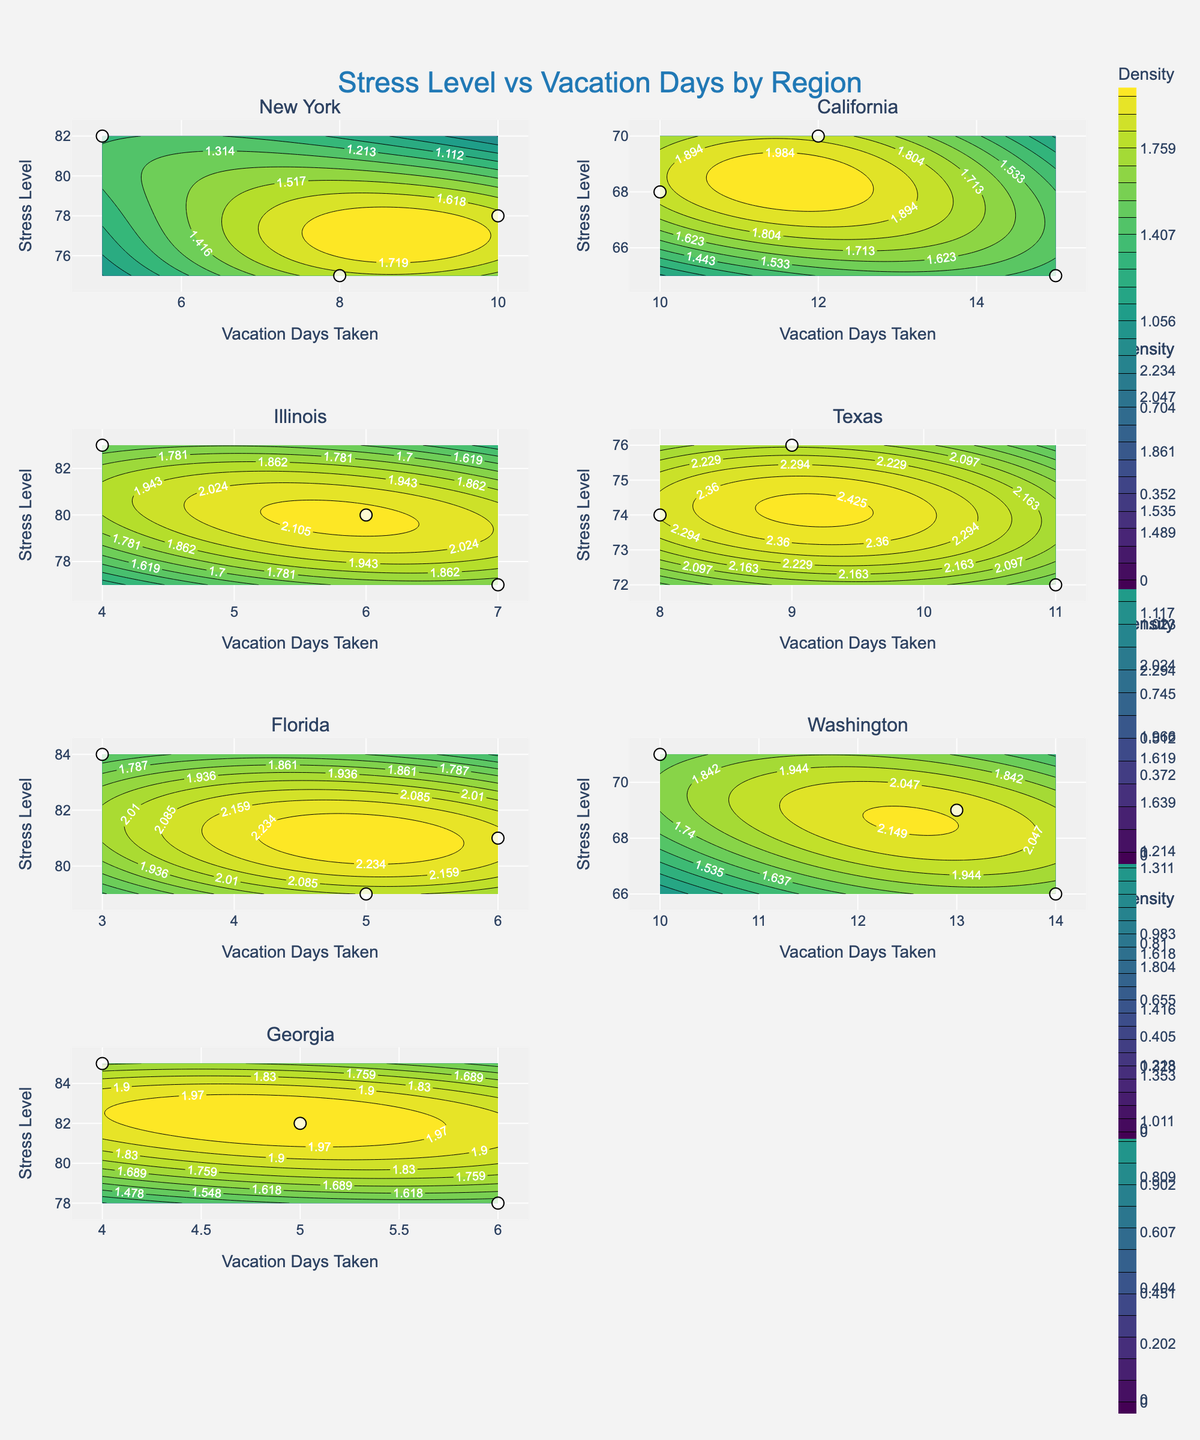what is the title of the figure? The title at the top of the figure is given in a prominent font size and color, making it easily readable.
Answer: Stress Level vs Vacation Days by Region how are the axes labeled? Each subplot has two axes. The x-axis of all subplots is labeled as 'Vacation Days Taken,' and the y-axis is labeled as 'Stress Level.'
Answer: 'Vacation Days Taken' for x-axis and 'Stress Level' for y-axis Which region shows the highest density of stress levels between 70 and 75? By looking at the contour density in each subplot, we can observe which region has the more concentrated contours between the stress level range of 70 to 75.
Answer: California Which region has the highest number of stress levels above 80? To determine this, we need to identify which subplot has the most data points above the 80 stress level mark.
Answer: Georgia How many unique regions are depicted in the figure? The number of subplot titles, each representing a different region, indicates the number of unique regions depicted in the figure.
Answer: 7 Which region shows the widest spread in vacation days taken? By comparing the horizontal span of the data points in each subplot, we determine which subplot covers the widest range of vacation days.
Answer: New York In which region do the contours show the highest density of low stress levels with high vacation days taken? Observing the density and distribution of contours across subplots reveals which region has the highest density of low stress levels corresponding to high vacation days.
Answer: Washington Comparing New York and Florida, which region shows a stronger negative correlation between stress levels and vacation days taken? By visually examining the pattern of data points and contour distribution in the New York and Florida subplots, we look for a more pronounced downward trend.
Answer: New York For the region with the highest stress levels, what is the minimum number of vacation days taken? Identify the region with the highest peak stress level and note the corresponding minimum vacation days taken within that subplot.
Answer: 3 days in Florida What is the region with the most even distribution of stress levels across different vacation days? A region with contours spread more evenly signifies a more uniform distribution; we need to compare regions and their contour dispersal.
Answer: Texas 